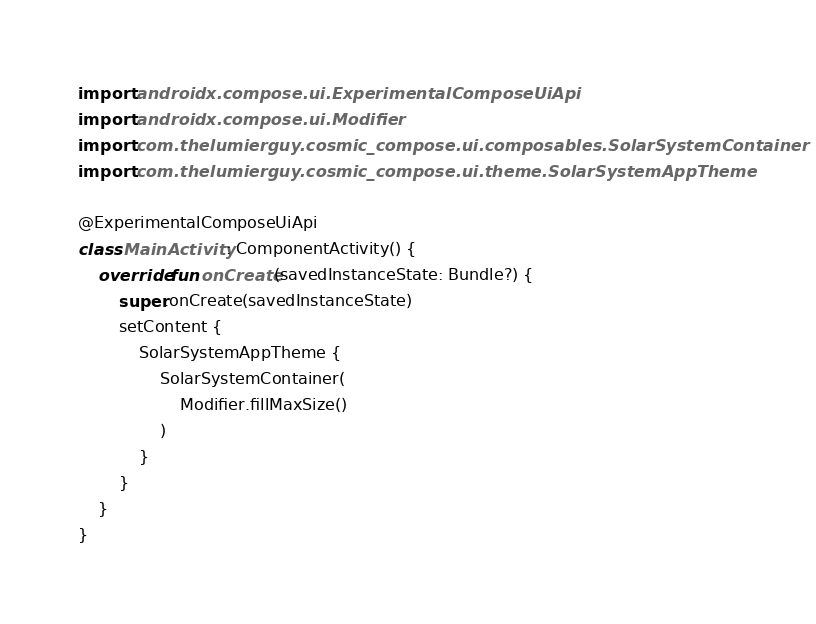<code> <loc_0><loc_0><loc_500><loc_500><_Kotlin_>import androidx.compose.ui.ExperimentalComposeUiApi
import androidx.compose.ui.Modifier
import com.thelumierguy.cosmic_compose.ui.composables.SolarSystemContainer
import com.thelumierguy.cosmic_compose.ui.theme.SolarSystemAppTheme

@ExperimentalComposeUiApi
class MainActivity : ComponentActivity() {
    override fun onCreate(savedInstanceState: Bundle?) {
        super.onCreate(savedInstanceState)
        setContent {
            SolarSystemAppTheme {
                SolarSystemContainer(
                    Modifier.fillMaxSize()
                )
            }
        }
    }
}</code> 